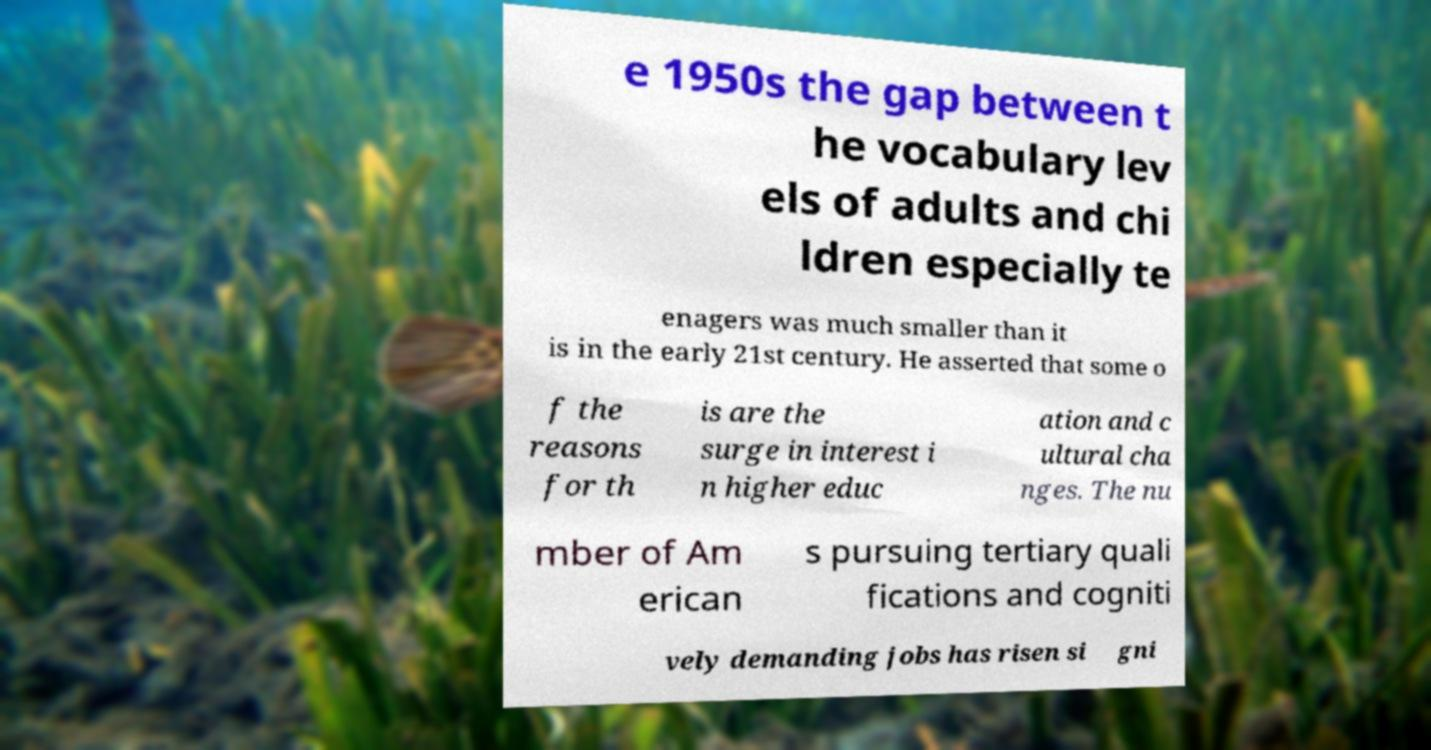I need the written content from this picture converted into text. Can you do that? e 1950s the gap between t he vocabulary lev els of adults and chi ldren especially te enagers was much smaller than it is in the early 21st century. He asserted that some o f the reasons for th is are the surge in interest i n higher educ ation and c ultural cha nges. The nu mber of Am erican s pursuing tertiary quali fications and cogniti vely demanding jobs has risen si gni 